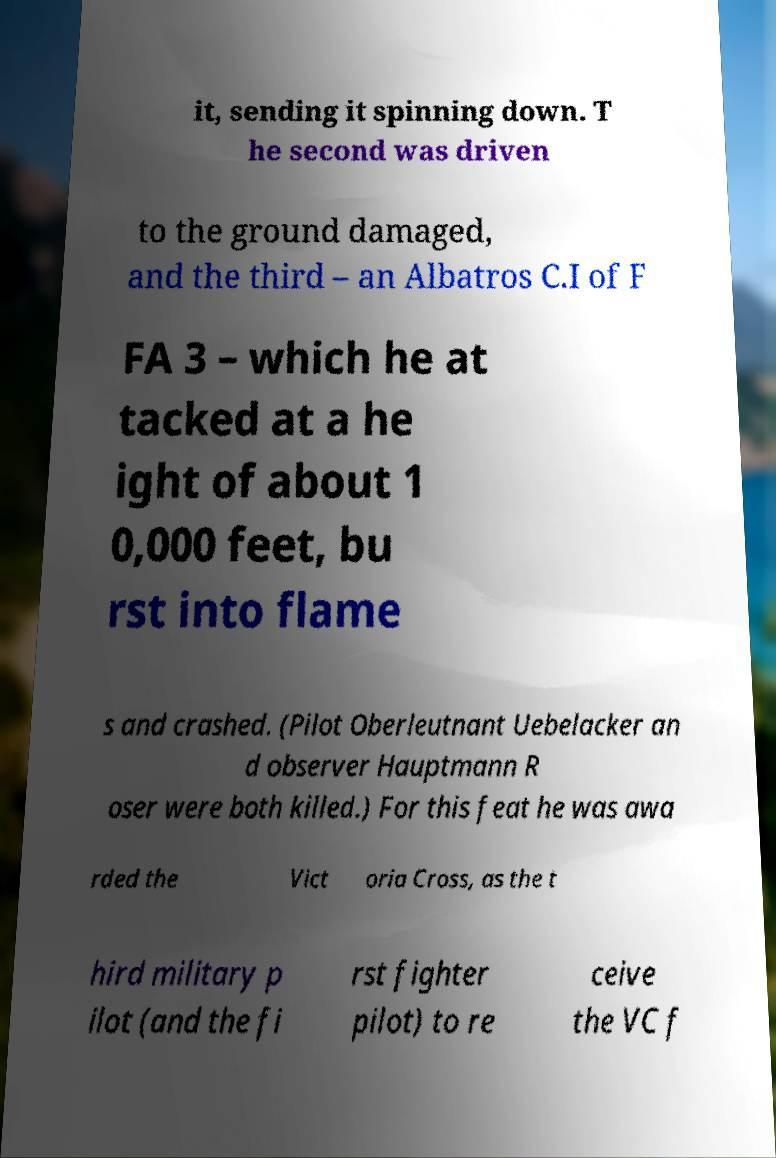I need the written content from this picture converted into text. Can you do that? it, sending it spinning down. T he second was driven to the ground damaged, and the third – an Albatros C.I of F FA 3 – which he at tacked at a he ight of about 1 0,000 feet, bu rst into flame s and crashed. (Pilot Oberleutnant Uebelacker an d observer Hauptmann R oser were both killed.) For this feat he was awa rded the Vict oria Cross, as the t hird military p ilot (and the fi rst fighter pilot) to re ceive the VC f 